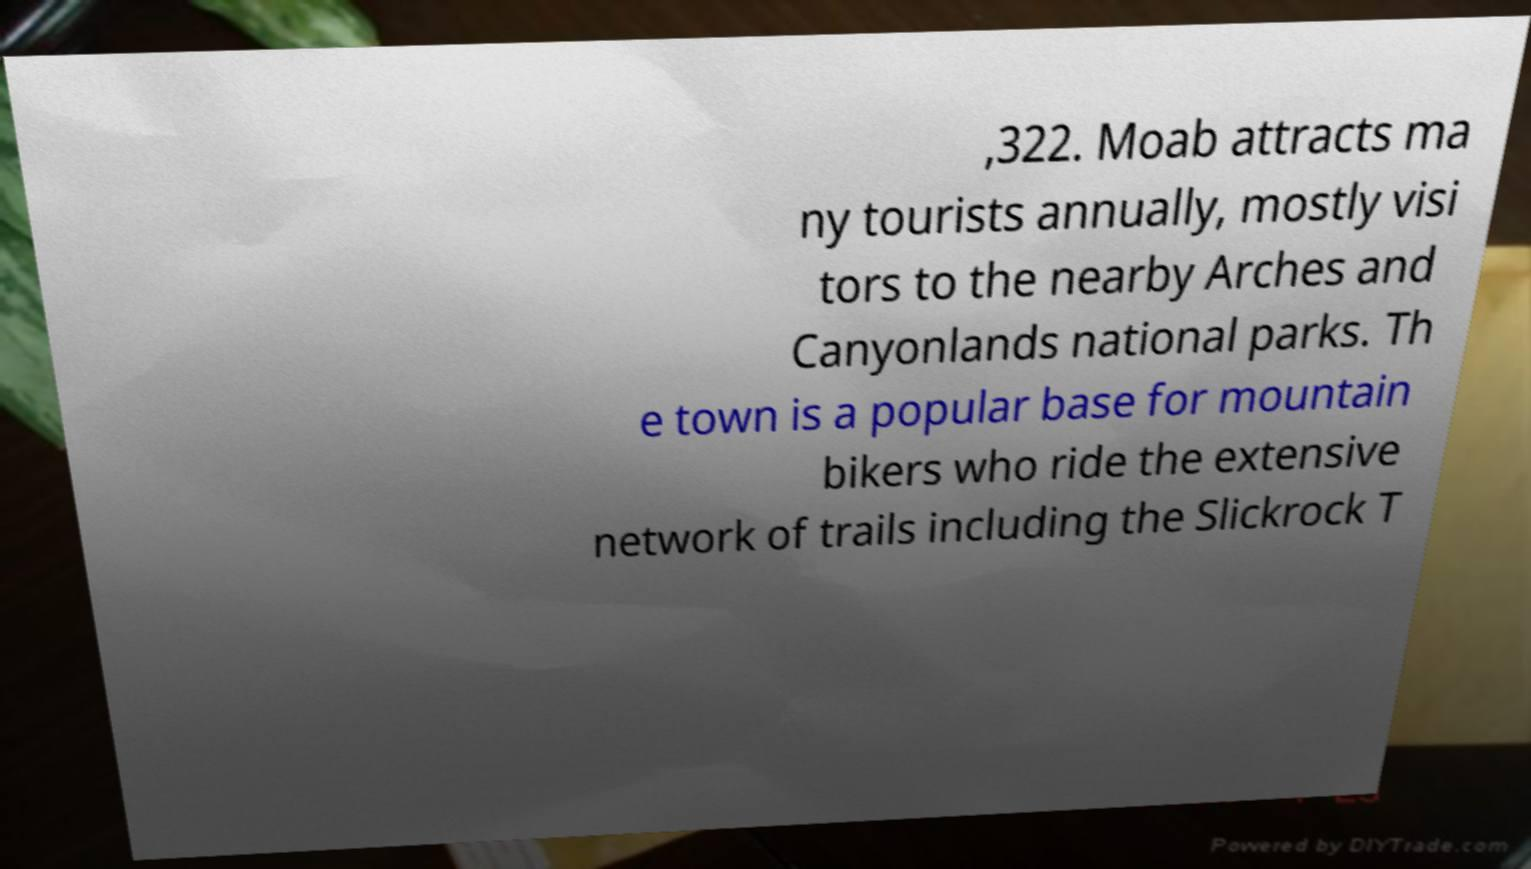Please read and relay the text visible in this image. What does it say? ,322. Moab attracts ma ny tourists annually, mostly visi tors to the nearby Arches and Canyonlands national parks. Th e town is a popular base for mountain bikers who ride the extensive network of trails including the Slickrock T 